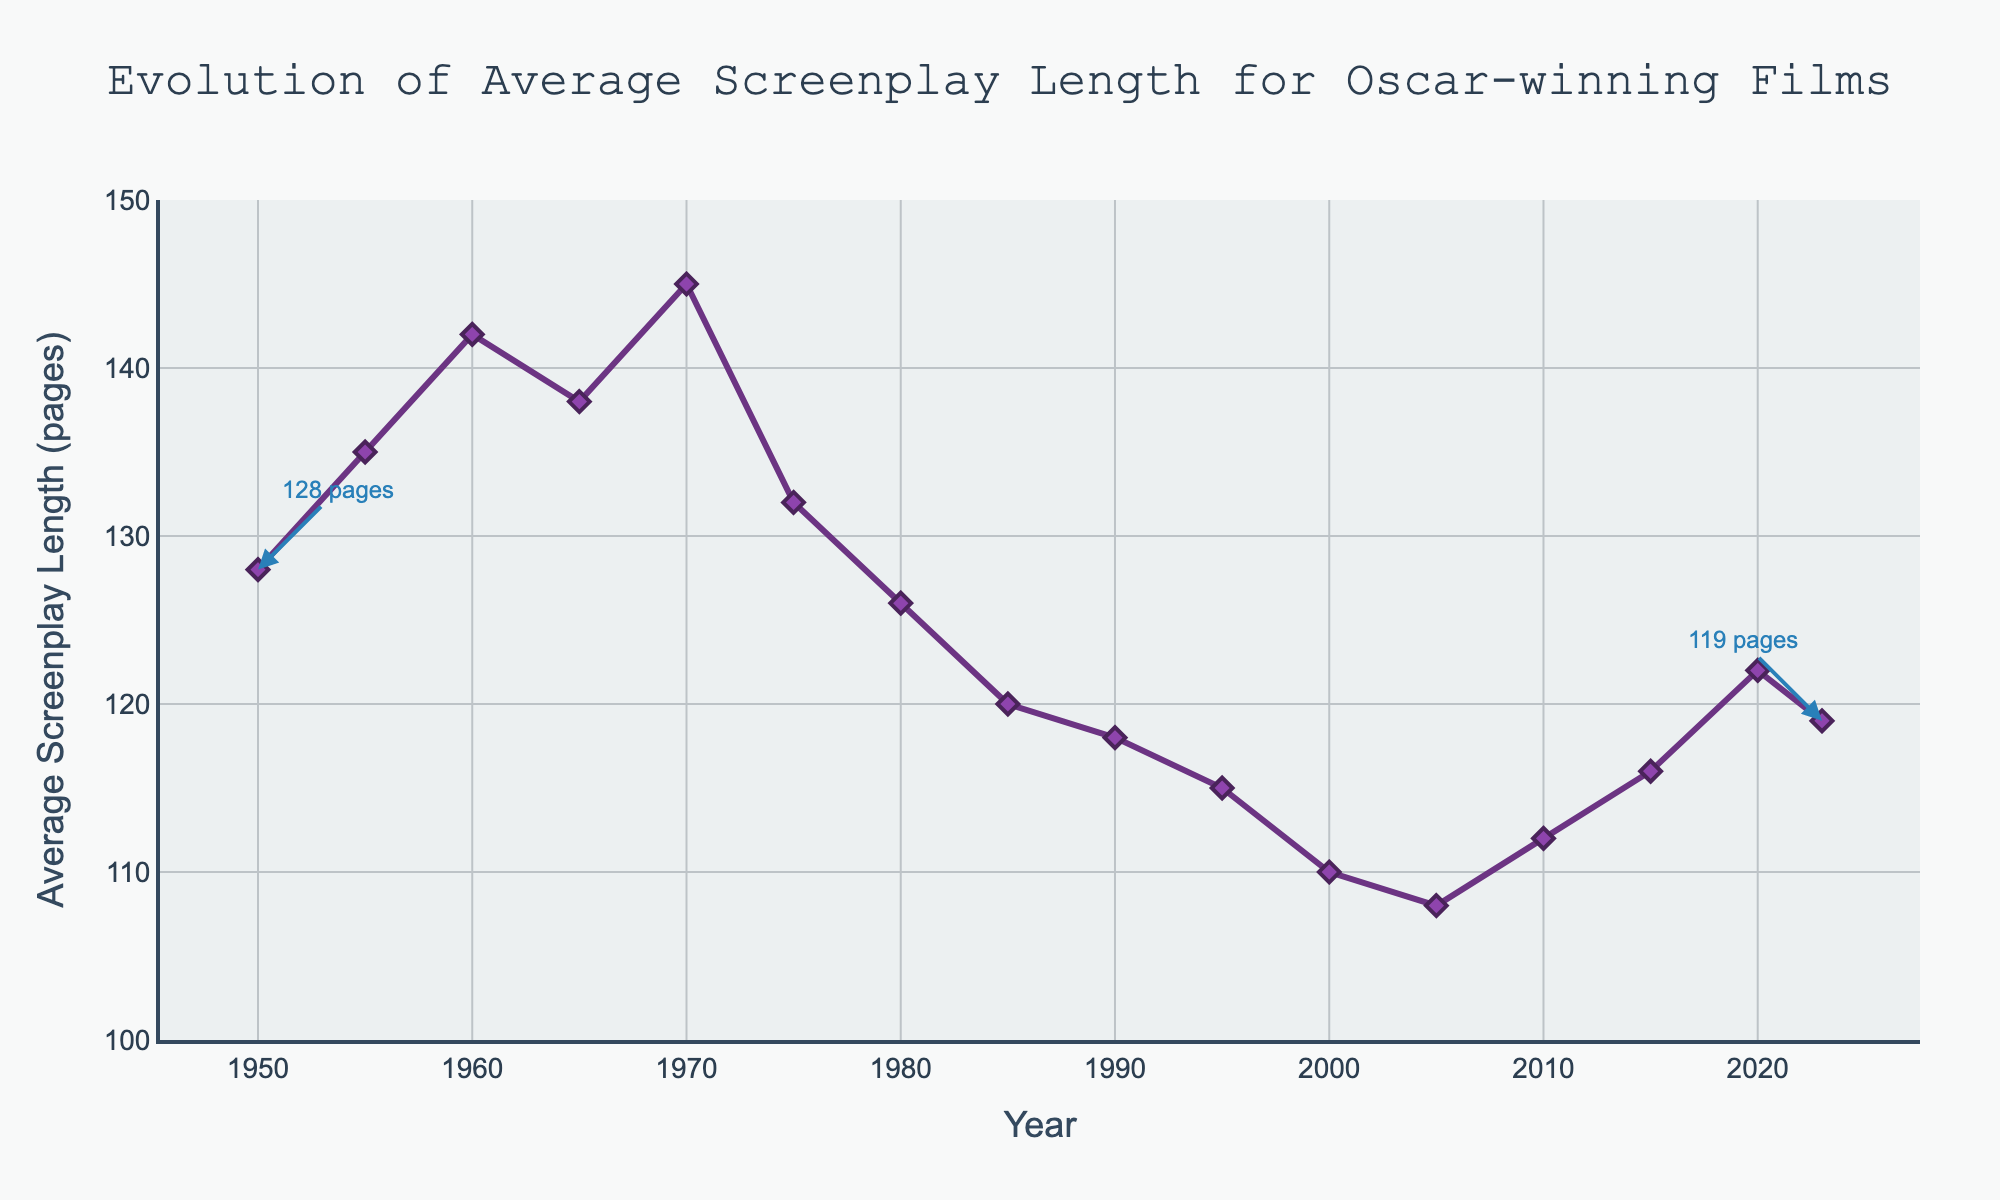What's the general trend of the average screenplay length from 1950 to 2023? From the figure, we observe the general trend of the average screenplay length starting at 128 pages in 1950, increasing until 1970, then decreasing with fluctuations until recent years.
Answer: Decreasing with fluctuations In which decade did the average screenplay length exhibit the highest value? By looking at the years on the x-axis and their corresponding points, it is clear that the highest value of 145 pages occurred in 1970 (within the 1970s decade).
Answer: 1970s What is the difference in the average screenplay length between 1950 and 2023? In 1950, the length was 128 pages, and in 2023, it was 119 pages. Subtracting these values: 128 - 119 = 9 pages.
Answer: 9 pages Which year had the shortest average screenplay length and what was it? By scanning the y-axis for the lowest point, it's observed that 2005 had the shortest length of 108 pages.
Answer: 2005, 108 pages Was there any period where the average screenplay length was consistently declining for more than 20 years? Observing the chart from 1970 (145 pages) to 1995 (115 pages), there's a consistent decline over a period of 25 years.
Answer: Yes (1970-1995) Between 1980 and 2000, which year had the largest increase in average screenplay length compared to the previous year? Analyzing the increments between consecutive years within 1980-2000, the largest increase is seen from 2005 (108 pages) to 2010 (112 pages), which is an increase of 4 pages.
Answer: 2010 Comparing 1960 and 2015, by how many pages did the average screenplay length reduce? The average length in 1960 was 142 pages, and in 2015 it was 116 pages, thus the reduction is 142 - 116 = 26 pages.
Answer: 26 pages During which decade did the average screenplay length have the biggest drop? Comparing the value drops for each decade, the biggest drop occurred from 1970 (145 pages) to 1980 (126 pages), dropping by 19 pages.
Answer: 1970s What was the percentage decrease in average screenplay length from 1970 to 1985? In 1970, the length was 145 pages, and in 1985, it was 120 pages. The percentage decrease is calculated as ((145 - 120) / 145) * 100 ≈ 17.24%.
Answer: 17.24% How many years have the average screenplay lengths been above 130 pages? From the figure, the lengths above 130 pages are observed in 1950, 1955, 1960, 1965, and 1970, counting a total of 5 years.
Answer: 5 years 